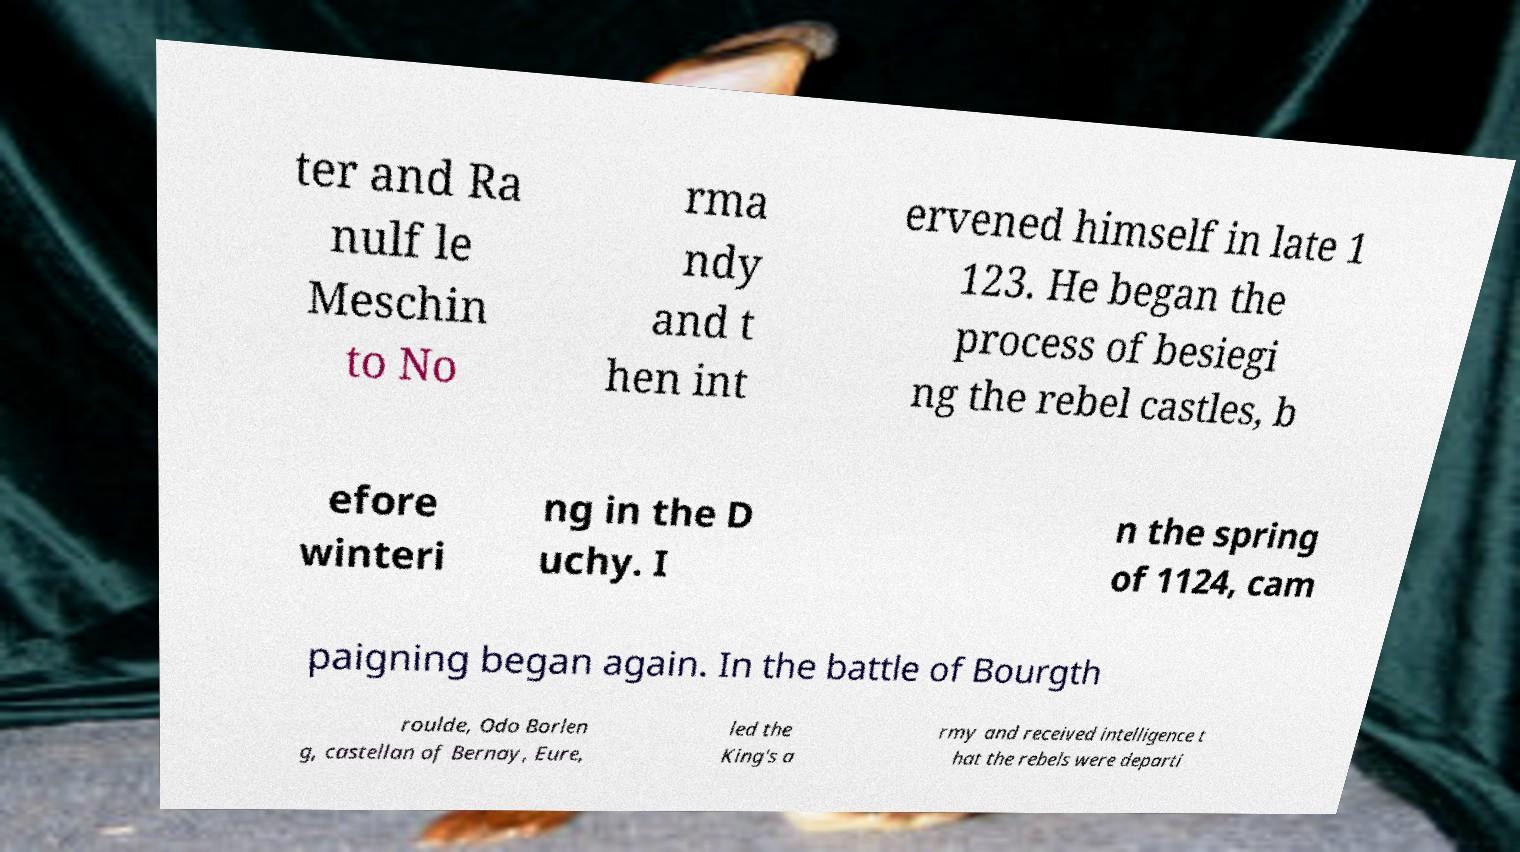For documentation purposes, I need the text within this image transcribed. Could you provide that? ter and Ra nulf le Meschin to No rma ndy and t hen int ervened himself in late 1 123. He began the process of besiegi ng the rebel castles, b efore winteri ng in the D uchy. I n the spring of 1124, cam paigning began again. In the battle of Bourgth roulde, Odo Borlen g, castellan of Bernay, Eure, led the King's a rmy and received intelligence t hat the rebels were departi 